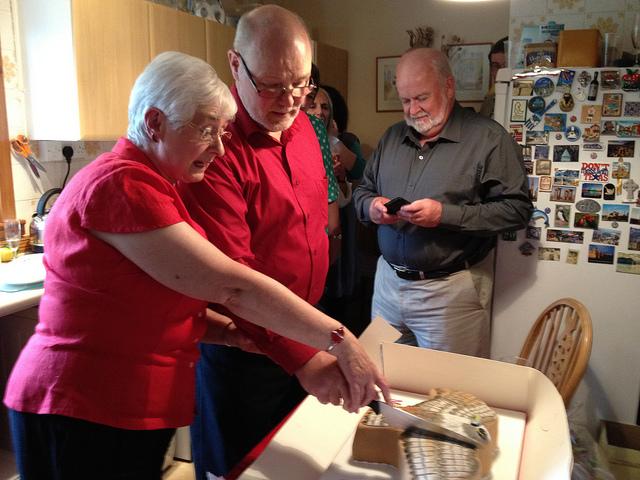What is the man in black shirt doing?
Keep it brief. Texting. Are they playing video games?
Keep it brief. No. What is in front of the man?
Be succinct. Cake. Is she wearing a dress?
Write a very short answer. No. Is this a wine tasting event?
Write a very short answer. No. Is the birthday cake look like a train?
Keep it brief. No. Is the lady playing?
Be succinct. No. Is the lady having trouble cutting the cake?
Be succinct. Yes. What is hanging next to the cabinets?
Concise answer only. Scissors. 